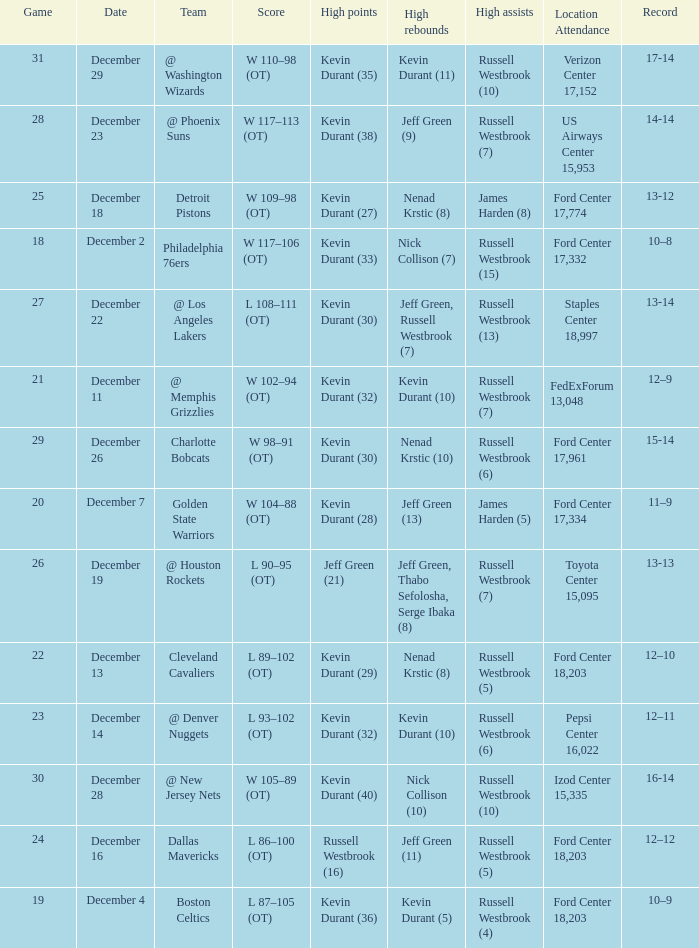What location attendance has russell westbrook (5) as high assists and nenad krstic (8) as high rebounds? Ford Center 18,203. 